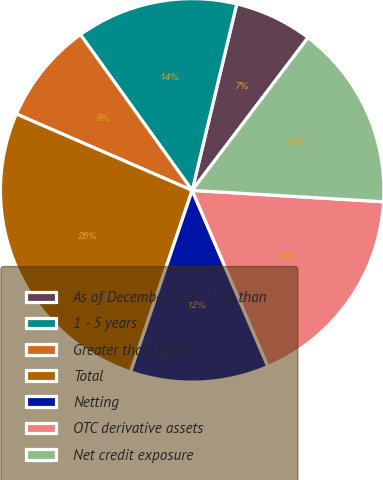Convert chart. <chart><loc_0><loc_0><loc_500><loc_500><pie_chart><fcel>As of December 2015 Less than<fcel>1 - 5 years<fcel>Greater than 5 years<fcel>Total<fcel>Netting<fcel>OTC derivative assets<fcel>Net credit exposure<nl><fcel>6.59%<fcel>13.64%<fcel>8.57%<fcel>26.32%<fcel>11.67%<fcel>17.59%<fcel>15.62%<nl></chart> 